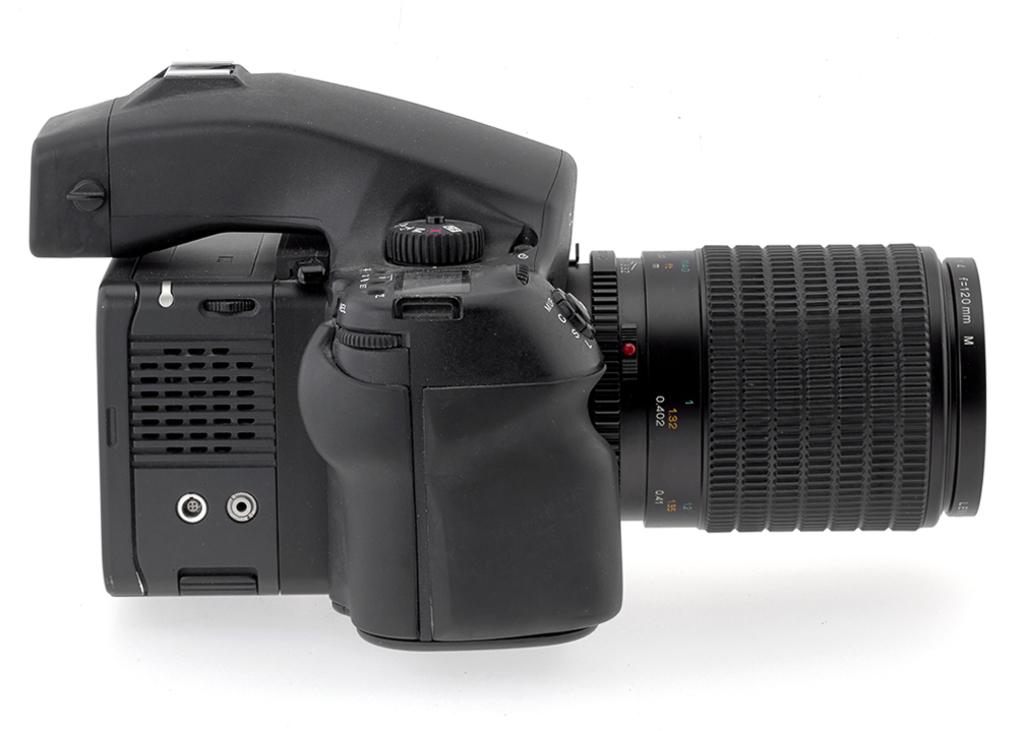What is the main object in the image? There is a camera in the image. What part of the camera is specifically mentioned in the facts? The camera has a lens. Where is the camera and lens located in the image? The camera and lens are placed on a surface. How does the camera contribute to society in the image? The image does not provide information about the camera's contribution to society; it only shows the camera and lens on a surface. 